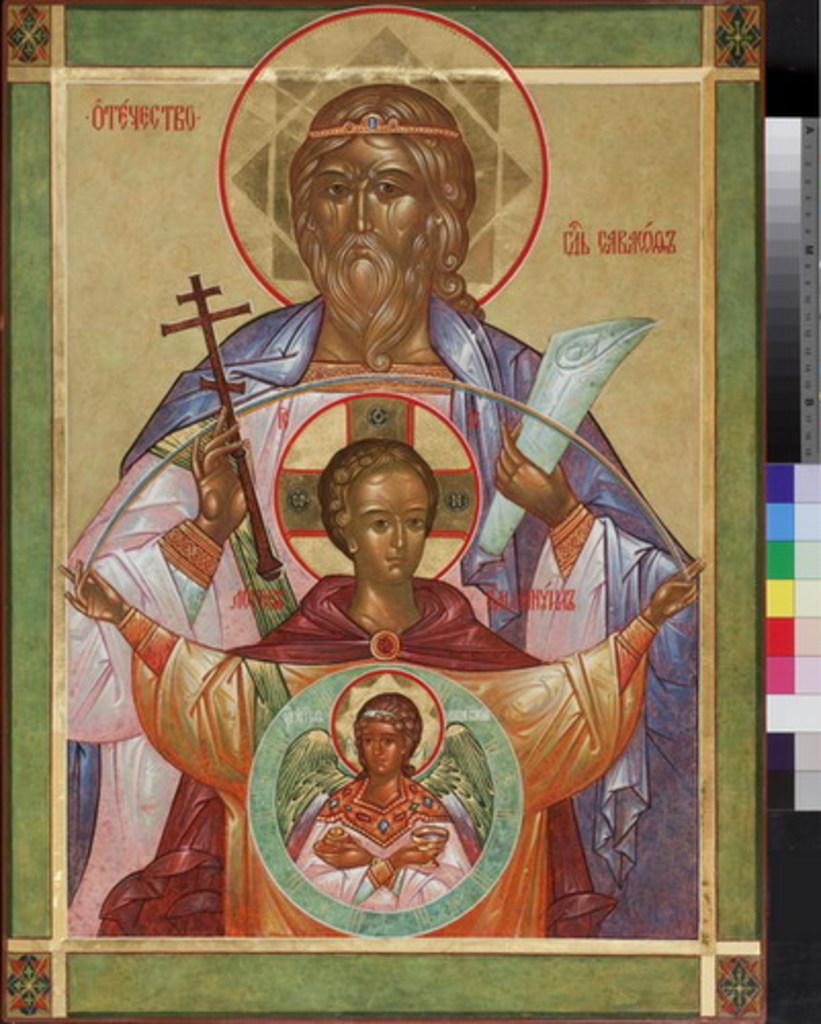What is the main subject of the image? The main subject of the image is a painting. What does the painting depict? The painting depicts three people. Are there any other elements in the painting besides the people? Yes, there are objects present in the painting. How is the painting displayed in the image? The painting is on a board. What type of pies are being served in the painting? There are no pies present in the painting; it depicts three people and various objects. How many mittens can be seen in the painting? There are no mittens present in the painting; it depicts three people and various objects. 